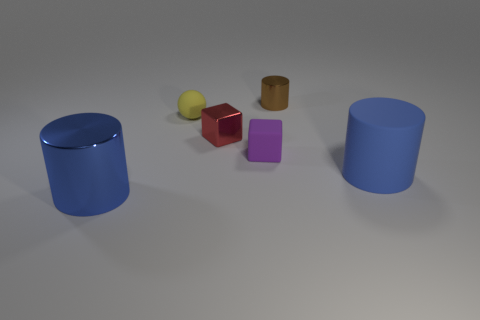Are there any small purple objects on the left side of the blue cylinder that is to the left of the metal cylinder that is behind the yellow rubber sphere?
Your answer should be compact. No. Are there fewer metallic objects than purple metal spheres?
Your answer should be compact. No. There is a big blue thing left of the brown metal object; is it the same shape as the purple matte thing?
Give a very brief answer. No. Are there any small brown cylinders?
Ensure brevity in your answer.  Yes. What is the color of the tiny cube behind the tiny purple cube that is in front of the matte object that is on the left side of the small red block?
Your response must be concise. Red. Are there the same number of purple cubes left of the tiny red block and shiny things that are behind the small brown metal thing?
Provide a succinct answer. Yes. The rubber thing that is the same size as the yellow ball is what shape?
Offer a very short reply. Cube. Are there any tiny cylinders of the same color as the metallic block?
Provide a short and direct response. No. What shape is the blue object on the right side of the ball?
Your answer should be very brief. Cylinder. The small matte block has what color?
Your answer should be compact. Purple. 